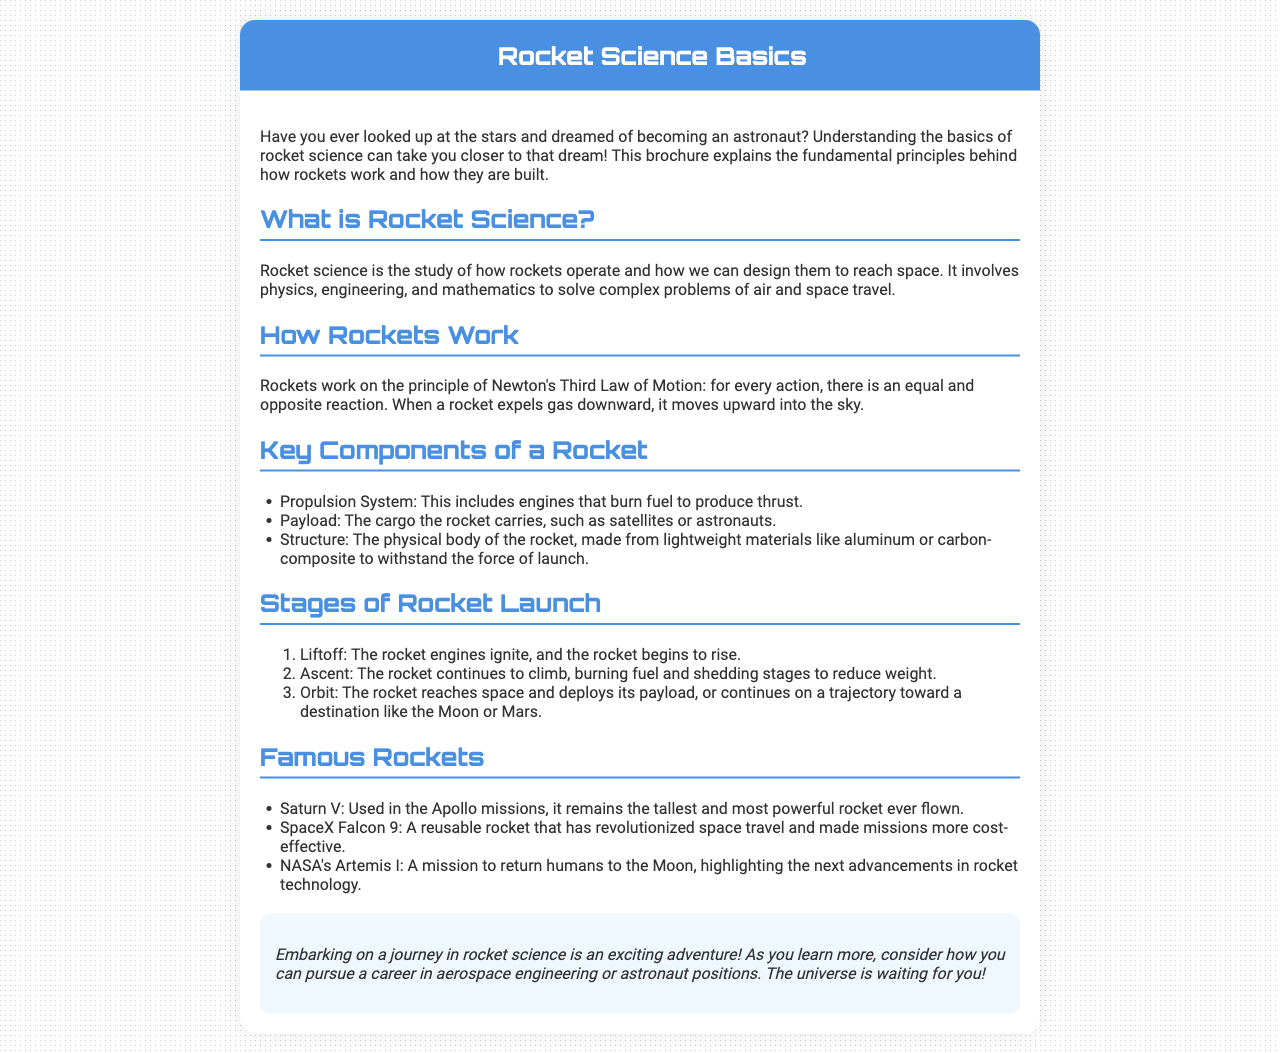What is rocket science? The document defines rocket science as the study of how rockets operate and how we can design them to reach space.
Answer: Study of how rockets operate What is the principle that rockets work on? The principle is Newton's Third Law of Motion: for every action, there is an equal and opposite reaction.
Answer: Newton's Third Law of Motion What are the three key components of a rocket? The document lists propulsion system, payload, and structure as the key components of a rocket.
Answer: Propulsion system, payload, structure What is the first stage of a rocket launch? The first stage is specified as Liftoff, where the rocket engines ignite and the rocket begins to rise.
Answer: Liftoff Which rocket is known as the tallest and most powerful ever flown? The document mentions Saturn V as the tallest and most powerful rocket ever flown.
Answer: Saturn V How many stages are there in the rocket launch process? The document outlines three stages: Liftoff, Ascent, and Orbit.
Answer: Three What significant mission does NASA's Artemis I represent? The document states that Artemis I is a mission to return humans to the Moon.
Answer: Return humans to the Moon What type of rocket is the SpaceX Falcon 9? The Falcon 9 is described as a reusable rocket.
Answer: Reusable rocket What does the conclusion of the brochure encourage readers to consider? The conclusion encourages readers to consider pursuing a career in aerospace engineering or astronaut positions.
Answer: Career in aerospace engineering or astronaut positions 